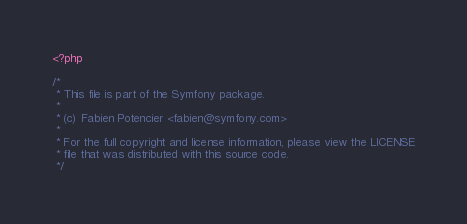<code> <loc_0><loc_0><loc_500><loc_500><_PHP_><?php

/*
 * This file is part of the Symfony package.
 *
 * (c) Fabien Potencier <fabien@symfony.com>
 *
 * For the full copyright and license information, please view the LICENSE
 * file that was distributed with this source code.
 */
</code> 